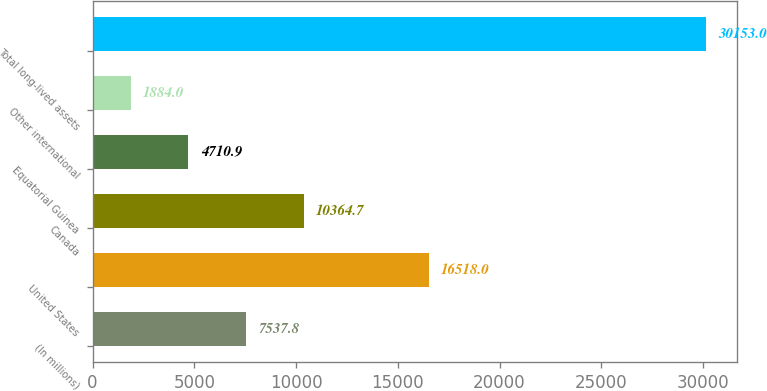Convert chart. <chart><loc_0><loc_0><loc_500><loc_500><bar_chart><fcel>(In millions)<fcel>United States<fcel>Canada<fcel>Equatorial Guinea<fcel>Other international<fcel>Total long-lived assets<nl><fcel>7537.8<fcel>16518<fcel>10364.7<fcel>4710.9<fcel>1884<fcel>30153<nl></chart> 